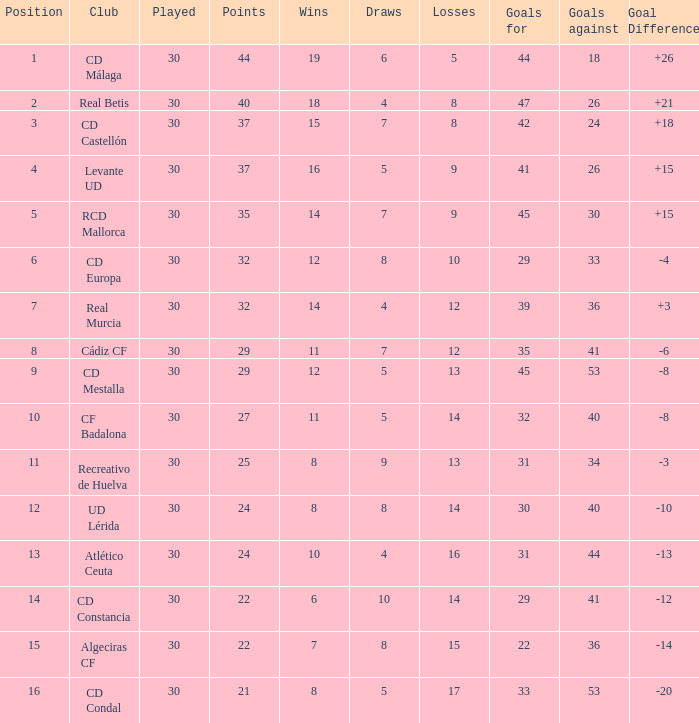What is the number of wins when the goals against is larger than 41, points is 29, and draws are larger than 5? 0.0. 